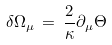Convert formula to latex. <formula><loc_0><loc_0><loc_500><loc_500>\delta \Omega _ { \mu } \, = \, \frac { 2 } { \kappa } \partial _ { \mu } \Theta</formula> 